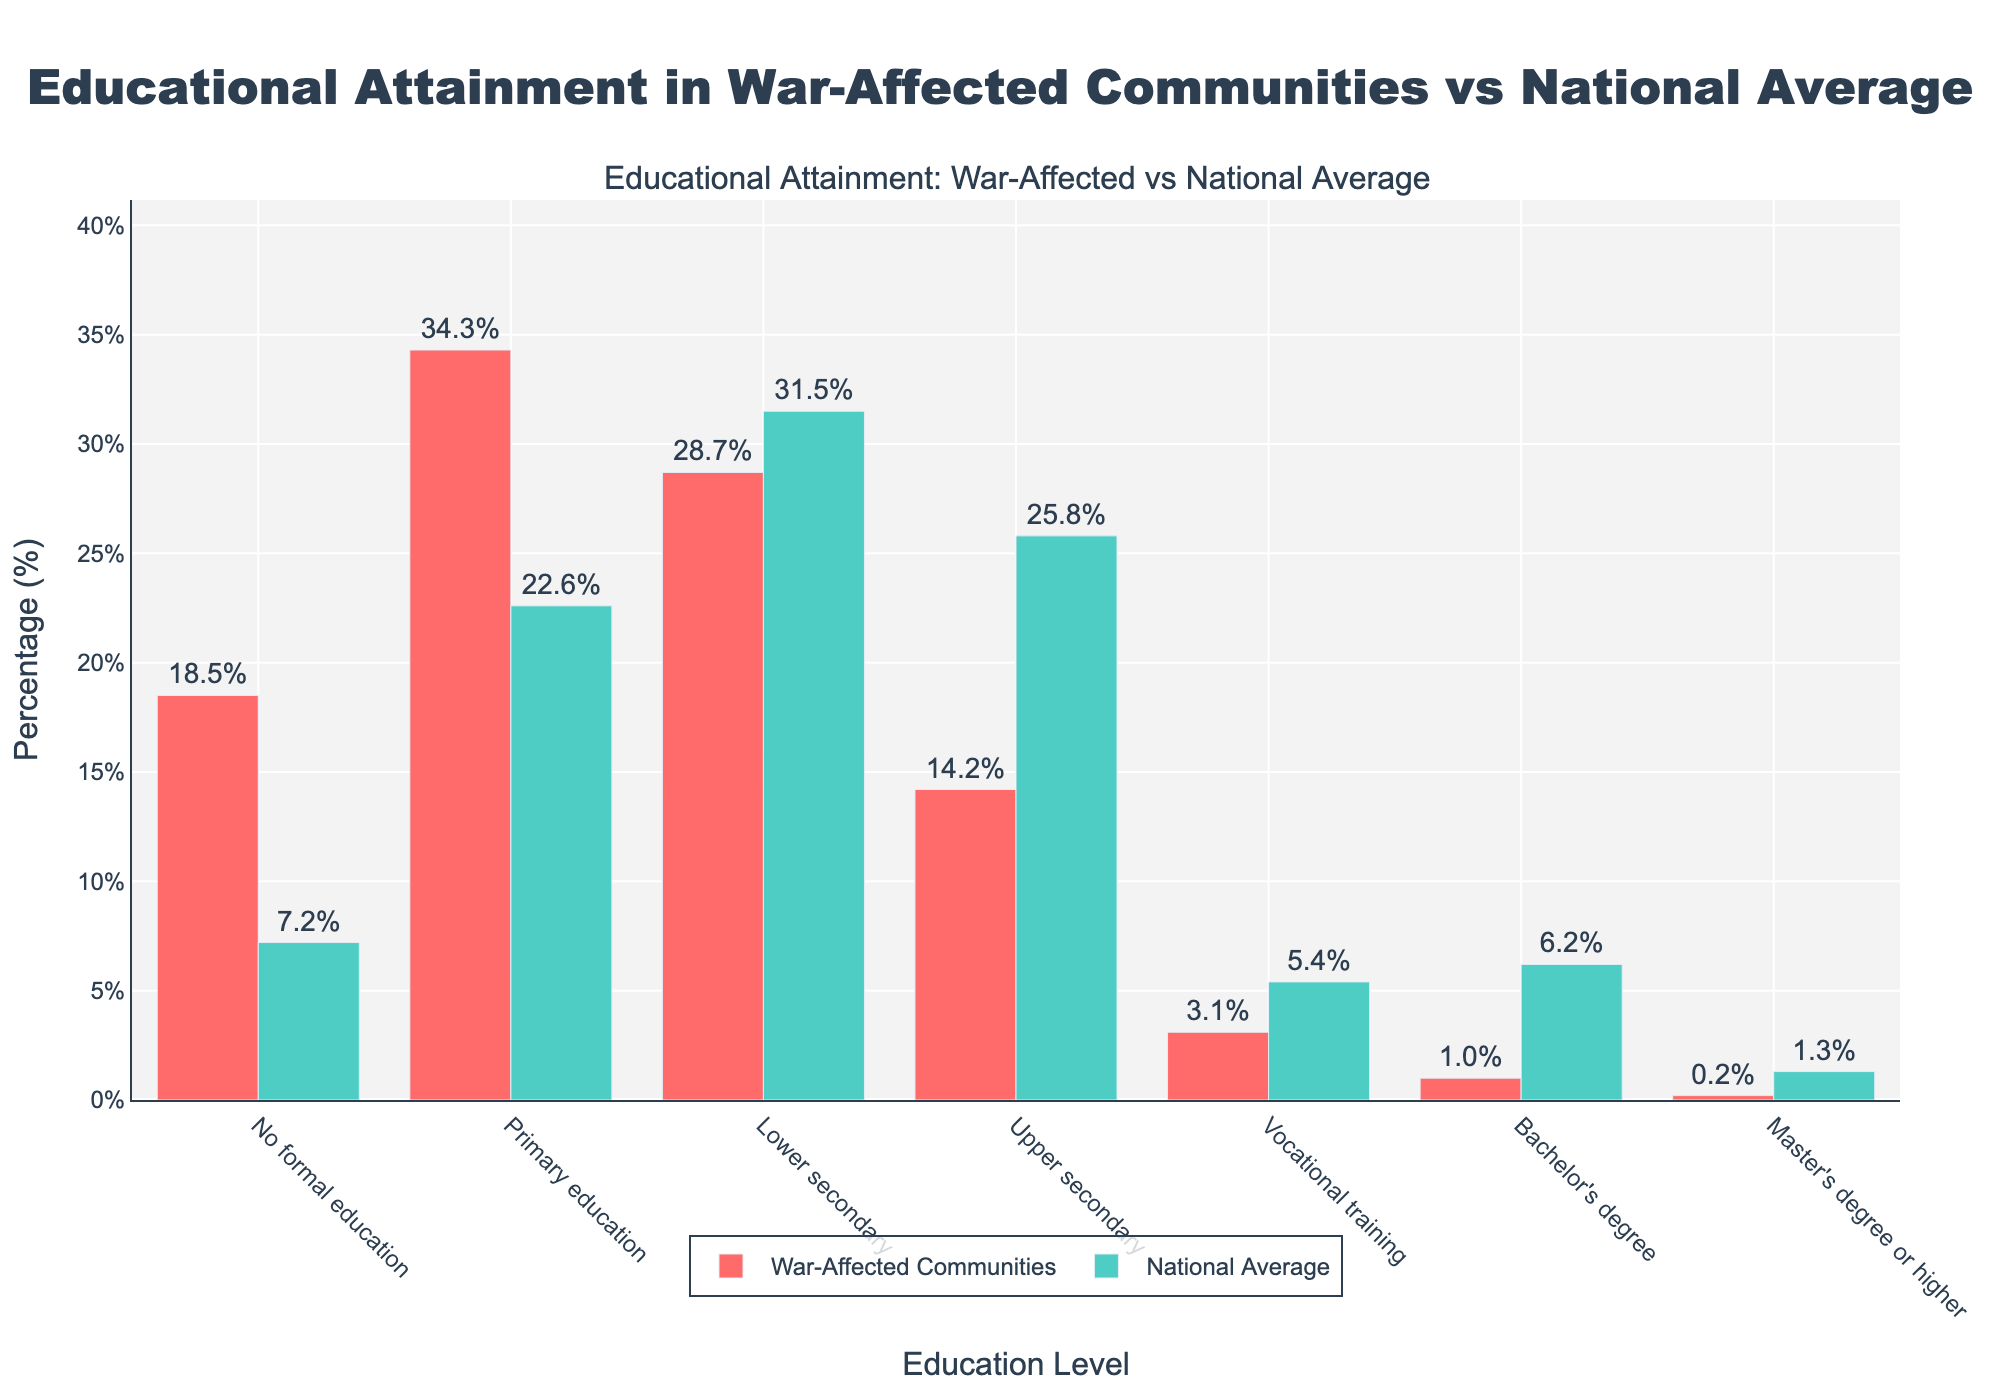What education level has the largest discrepancy between war-affected communities and the national average? The largest discrepancy occurs at the level with the highest difference in percentages. By comparing each level, we see that 'Primary education' has a discrepancy of 34.3% (war-affected) - 22.6% (national average) = 11.7%.
Answer: Primary education What's the percentage difference in the population holding a bachelor's degree between war-affected communities and national averages? For bachelor's degrees, the difference is calculated as 6.2% (national) - 1.0% (war-affected) = 5.2%.
Answer: 5.2% What is the combined percentage of individuals with upper secondary and vocational training in war-affected communities? Summing the percentages for 'Upper secondary' and 'Vocational training' in war-affected communities: 14.2% + 3.1% = 17.3%.
Answer: 17.3% How does the percentage of individuals with no formal education in war-affected communities compare to the national average? Comparing the percentages for 'No formal education': 18.5% (war-affected) vs 7.2% (national). It's clear that the war-affected communities have a significantly higher percentage.
Answer: Higher in war-affected Which education level has the closest percentages between war-affected communities and the national average? By comparing all education levels, 'Lower secondary' shows the closest percentages: 28.7% (war-affected) vs 31.5% (national).
Answer: Lower secondary What is the total percentage of individuals with at least a bachelor's degree in war-affected communities? Adding the percentages for 'Bachelor's degree' and ‘Master's degree or higher’: 1.0% + 0.2% = 1.2%.
Answer: 1.2% In which category do war-affected communities surpass the national average percentage? By comparing each category, 'No formal education' (18.5% war-affected vs 7.2% national) and 'Primary education' (34.3% war-affected vs 22.6% national) are the categories where war-affected communities surpass the national average.
Answer: No formal education and Primary education Which community has a higher percentage of individuals with vocational training? Comparing percentages for 'Vocational training': 5.4% in the national average vs 3.1% in war-affected communities. The national average is higher.
Answer: National average 